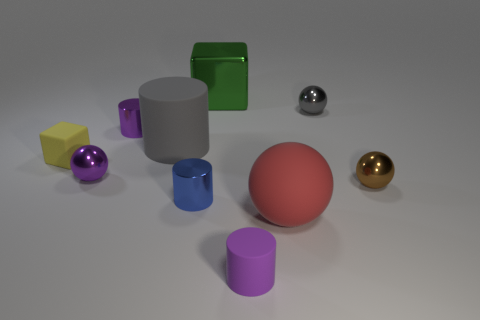Subtract all purple cylinders. How many were subtracted if there are1purple cylinders left? 1 Subtract all blocks. How many objects are left? 8 Add 4 small gray balls. How many small gray balls exist? 5 Subtract 1 gray spheres. How many objects are left? 9 Subtract all green things. Subtract all gray rubber cylinders. How many objects are left? 8 Add 8 gray metal balls. How many gray metal balls are left? 9 